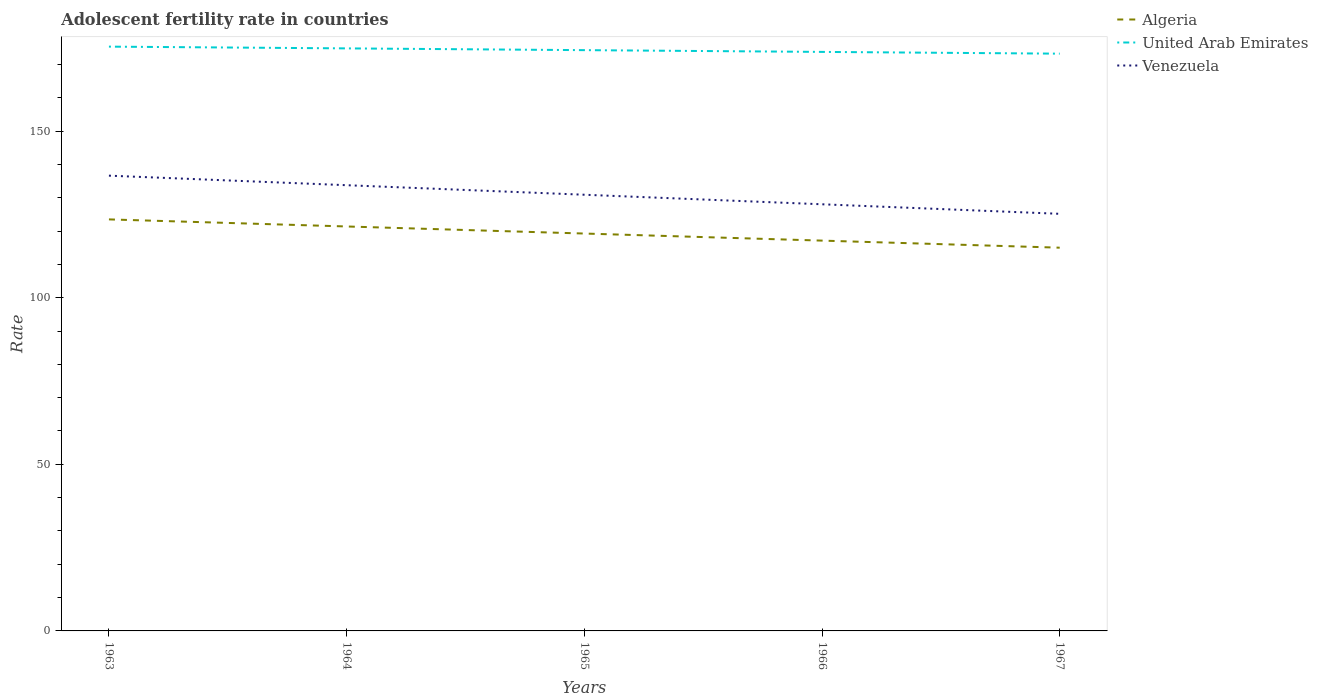Is the number of lines equal to the number of legend labels?
Give a very brief answer. Yes. Across all years, what is the maximum adolescent fertility rate in United Arab Emirates?
Offer a terse response. 173.24. In which year was the adolescent fertility rate in Venezuela maximum?
Your answer should be very brief. 1967. What is the total adolescent fertility rate in United Arab Emirates in the graph?
Your answer should be very brief. 0.53. What is the difference between the highest and the second highest adolescent fertility rate in Algeria?
Provide a succinct answer. 8.49. What is the difference between the highest and the lowest adolescent fertility rate in United Arab Emirates?
Keep it short and to the point. 2. What is the difference between two consecutive major ticks on the Y-axis?
Offer a very short reply. 50. Does the graph contain any zero values?
Provide a succinct answer. No. How are the legend labels stacked?
Your answer should be compact. Vertical. What is the title of the graph?
Provide a short and direct response. Adolescent fertility rate in countries. Does "Argentina" appear as one of the legend labels in the graph?
Keep it short and to the point. No. What is the label or title of the Y-axis?
Provide a short and direct response. Rate. What is the Rate of Algeria in 1963?
Give a very brief answer. 123.5. What is the Rate of United Arab Emirates in 1963?
Give a very brief answer. 175.35. What is the Rate of Venezuela in 1963?
Offer a terse response. 136.63. What is the Rate of Algeria in 1964?
Provide a short and direct response. 121.38. What is the Rate in United Arab Emirates in 1964?
Give a very brief answer. 174.82. What is the Rate of Venezuela in 1964?
Provide a short and direct response. 133.76. What is the Rate in Algeria in 1965?
Your response must be concise. 119.26. What is the Rate in United Arab Emirates in 1965?
Your answer should be very brief. 174.3. What is the Rate of Venezuela in 1965?
Your response must be concise. 130.9. What is the Rate in Algeria in 1966?
Keep it short and to the point. 117.13. What is the Rate in United Arab Emirates in 1966?
Your answer should be very brief. 173.77. What is the Rate of Venezuela in 1966?
Keep it short and to the point. 128.04. What is the Rate of Algeria in 1967?
Make the answer very short. 115.01. What is the Rate of United Arab Emirates in 1967?
Ensure brevity in your answer.  173.24. What is the Rate of Venezuela in 1967?
Your answer should be very brief. 125.17. Across all years, what is the maximum Rate of Algeria?
Your answer should be compact. 123.5. Across all years, what is the maximum Rate of United Arab Emirates?
Offer a terse response. 175.35. Across all years, what is the maximum Rate of Venezuela?
Your answer should be very brief. 136.63. Across all years, what is the minimum Rate of Algeria?
Give a very brief answer. 115.01. Across all years, what is the minimum Rate of United Arab Emirates?
Provide a succinct answer. 173.24. Across all years, what is the minimum Rate of Venezuela?
Offer a very short reply. 125.17. What is the total Rate in Algeria in the graph?
Your answer should be very brief. 596.28. What is the total Rate of United Arab Emirates in the graph?
Make the answer very short. 871.48. What is the total Rate in Venezuela in the graph?
Offer a terse response. 654.51. What is the difference between the Rate in Algeria in 1963 and that in 1964?
Your answer should be compact. 2.12. What is the difference between the Rate in United Arab Emirates in 1963 and that in 1964?
Keep it short and to the point. 0.53. What is the difference between the Rate of Venezuela in 1963 and that in 1964?
Your answer should be very brief. 2.86. What is the difference between the Rate in Algeria in 1963 and that in 1965?
Offer a terse response. 4.24. What is the difference between the Rate in United Arab Emirates in 1963 and that in 1965?
Ensure brevity in your answer.  1.06. What is the difference between the Rate of Venezuela in 1963 and that in 1965?
Provide a short and direct response. 5.73. What is the difference between the Rate in Algeria in 1963 and that in 1966?
Provide a short and direct response. 6.37. What is the difference between the Rate of United Arab Emirates in 1963 and that in 1966?
Your answer should be very brief. 1.58. What is the difference between the Rate of Venezuela in 1963 and that in 1966?
Keep it short and to the point. 8.59. What is the difference between the Rate in Algeria in 1963 and that in 1967?
Your response must be concise. 8.49. What is the difference between the Rate of United Arab Emirates in 1963 and that in 1967?
Offer a very short reply. 2.11. What is the difference between the Rate of Venezuela in 1963 and that in 1967?
Provide a short and direct response. 11.45. What is the difference between the Rate in Algeria in 1964 and that in 1965?
Offer a terse response. 2.12. What is the difference between the Rate of United Arab Emirates in 1964 and that in 1965?
Ensure brevity in your answer.  0.53. What is the difference between the Rate in Venezuela in 1964 and that in 1965?
Provide a short and direct response. 2.86. What is the difference between the Rate of Algeria in 1964 and that in 1966?
Ensure brevity in your answer.  4.24. What is the difference between the Rate in United Arab Emirates in 1964 and that in 1966?
Offer a terse response. 1.06. What is the difference between the Rate in Venezuela in 1964 and that in 1966?
Keep it short and to the point. 5.73. What is the difference between the Rate of Algeria in 1964 and that in 1967?
Ensure brevity in your answer.  6.37. What is the difference between the Rate in United Arab Emirates in 1964 and that in 1967?
Provide a short and direct response. 1.58. What is the difference between the Rate in Venezuela in 1964 and that in 1967?
Offer a terse response. 8.59. What is the difference between the Rate of Algeria in 1965 and that in 1966?
Your answer should be compact. 2.12. What is the difference between the Rate of United Arab Emirates in 1965 and that in 1966?
Offer a very short reply. 0.53. What is the difference between the Rate in Venezuela in 1965 and that in 1966?
Offer a terse response. 2.86. What is the difference between the Rate in Algeria in 1965 and that in 1967?
Keep it short and to the point. 4.24. What is the difference between the Rate of United Arab Emirates in 1965 and that in 1967?
Provide a short and direct response. 1.06. What is the difference between the Rate in Venezuela in 1965 and that in 1967?
Offer a terse response. 5.73. What is the difference between the Rate of Algeria in 1966 and that in 1967?
Provide a short and direct response. 2.12. What is the difference between the Rate in United Arab Emirates in 1966 and that in 1967?
Your answer should be compact. 0.53. What is the difference between the Rate in Venezuela in 1966 and that in 1967?
Make the answer very short. 2.86. What is the difference between the Rate of Algeria in 1963 and the Rate of United Arab Emirates in 1964?
Make the answer very short. -51.32. What is the difference between the Rate of Algeria in 1963 and the Rate of Venezuela in 1964?
Your answer should be compact. -10.26. What is the difference between the Rate in United Arab Emirates in 1963 and the Rate in Venezuela in 1964?
Give a very brief answer. 41.59. What is the difference between the Rate of Algeria in 1963 and the Rate of United Arab Emirates in 1965?
Give a very brief answer. -50.79. What is the difference between the Rate in Algeria in 1963 and the Rate in Venezuela in 1965?
Give a very brief answer. -7.4. What is the difference between the Rate in United Arab Emirates in 1963 and the Rate in Venezuela in 1965?
Your answer should be very brief. 44.45. What is the difference between the Rate of Algeria in 1963 and the Rate of United Arab Emirates in 1966?
Your answer should be very brief. -50.27. What is the difference between the Rate in Algeria in 1963 and the Rate in Venezuela in 1966?
Provide a short and direct response. -4.54. What is the difference between the Rate in United Arab Emirates in 1963 and the Rate in Venezuela in 1966?
Keep it short and to the point. 47.31. What is the difference between the Rate in Algeria in 1963 and the Rate in United Arab Emirates in 1967?
Your answer should be very brief. -49.74. What is the difference between the Rate of Algeria in 1963 and the Rate of Venezuela in 1967?
Provide a short and direct response. -1.67. What is the difference between the Rate of United Arab Emirates in 1963 and the Rate of Venezuela in 1967?
Give a very brief answer. 50.18. What is the difference between the Rate in Algeria in 1964 and the Rate in United Arab Emirates in 1965?
Keep it short and to the point. -52.92. What is the difference between the Rate in Algeria in 1964 and the Rate in Venezuela in 1965?
Offer a terse response. -9.52. What is the difference between the Rate in United Arab Emirates in 1964 and the Rate in Venezuela in 1965?
Ensure brevity in your answer.  43.92. What is the difference between the Rate of Algeria in 1964 and the Rate of United Arab Emirates in 1966?
Keep it short and to the point. -52.39. What is the difference between the Rate of Algeria in 1964 and the Rate of Venezuela in 1966?
Give a very brief answer. -6.66. What is the difference between the Rate of United Arab Emirates in 1964 and the Rate of Venezuela in 1966?
Offer a terse response. 46.78. What is the difference between the Rate of Algeria in 1964 and the Rate of United Arab Emirates in 1967?
Your response must be concise. -51.86. What is the difference between the Rate of Algeria in 1964 and the Rate of Venezuela in 1967?
Your response must be concise. -3.8. What is the difference between the Rate of United Arab Emirates in 1964 and the Rate of Venezuela in 1967?
Make the answer very short. 49.65. What is the difference between the Rate of Algeria in 1965 and the Rate of United Arab Emirates in 1966?
Offer a very short reply. -54.51. What is the difference between the Rate of Algeria in 1965 and the Rate of Venezuela in 1966?
Give a very brief answer. -8.78. What is the difference between the Rate in United Arab Emirates in 1965 and the Rate in Venezuela in 1966?
Provide a succinct answer. 46.26. What is the difference between the Rate of Algeria in 1965 and the Rate of United Arab Emirates in 1967?
Offer a terse response. -53.98. What is the difference between the Rate in Algeria in 1965 and the Rate in Venezuela in 1967?
Make the answer very short. -5.92. What is the difference between the Rate of United Arab Emirates in 1965 and the Rate of Venezuela in 1967?
Your response must be concise. 49.12. What is the difference between the Rate of Algeria in 1966 and the Rate of United Arab Emirates in 1967?
Offer a very short reply. -56.11. What is the difference between the Rate of Algeria in 1966 and the Rate of Venezuela in 1967?
Your response must be concise. -8.04. What is the difference between the Rate in United Arab Emirates in 1966 and the Rate in Venezuela in 1967?
Your answer should be very brief. 48.59. What is the average Rate of Algeria per year?
Give a very brief answer. 119.26. What is the average Rate in United Arab Emirates per year?
Your answer should be very brief. 174.3. What is the average Rate of Venezuela per year?
Give a very brief answer. 130.9. In the year 1963, what is the difference between the Rate of Algeria and Rate of United Arab Emirates?
Offer a very short reply. -51.85. In the year 1963, what is the difference between the Rate of Algeria and Rate of Venezuela?
Ensure brevity in your answer.  -13.13. In the year 1963, what is the difference between the Rate in United Arab Emirates and Rate in Venezuela?
Provide a succinct answer. 38.72. In the year 1964, what is the difference between the Rate in Algeria and Rate in United Arab Emirates?
Provide a succinct answer. -53.44. In the year 1964, what is the difference between the Rate of Algeria and Rate of Venezuela?
Provide a short and direct response. -12.39. In the year 1964, what is the difference between the Rate of United Arab Emirates and Rate of Venezuela?
Give a very brief answer. 41.06. In the year 1965, what is the difference between the Rate of Algeria and Rate of United Arab Emirates?
Offer a very short reply. -55.04. In the year 1965, what is the difference between the Rate in Algeria and Rate in Venezuela?
Your response must be concise. -11.64. In the year 1965, what is the difference between the Rate in United Arab Emirates and Rate in Venezuela?
Provide a short and direct response. 43.39. In the year 1966, what is the difference between the Rate in Algeria and Rate in United Arab Emirates?
Make the answer very short. -56.63. In the year 1966, what is the difference between the Rate of Algeria and Rate of Venezuela?
Provide a succinct answer. -10.9. In the year 1966, what is the difference between the Rate of United Arab Emirates and Rate of Venezuela?
Your response must be concise. 45.73. In the year 1967, what is the difference between the Rate of Algeria and Rate of United Arab Emirates?
Make the answer very short. -58.23. In the year 1967, what is the difference between the Rate in Algeria and Rate in Venezuela?
Your answer should be very brief. -10.16. In the year 1967, what is the difference between the Rate in United Arab Emirates and Rate in Venezuela?
Your response must be concise. 48.06. What is the ratio of the Rate of Algeria in 1963 to that in 1964?
Your answer should be compact. 1.02. What is the ratio of the Rate in United Arab Emirates in 1963 to that in 1964?
Provide a succinct answer. 1. What is the ratio of the Rate in Venezuela in 1963 to that in 1964?
Provide a short and direct response. 1.02. What is the ratio of the Rate in Algeria in 1963 to that in 1965?
Ensure brevity in your answer.  1.04. What is the ratio of the Rate in United Arab Emirates in 1963 to that in 1965?
Keep it short and to the point. 1.01. What is the ratio of the Rate in Venezuela in 1963 to that in 1965?
Your answer should be very brief. 1.04. What is the ratio of the Rate in Algeria in 1963 to that in 1966?
Offer a very short reply. 1.05. What is the ratio of the Rate of United Arab Emirates in 1963 to that in 1966?
Provide a succinct answer. 1.01. What is the ratio of the Rate of Venezuela in 1963 to that in 1966?
Your response must be concise. 1.07. What is the ratio of the Rate in Algeria in 1963 to that in 1967?
Provide a succinct answer. 1.07. What is the ratio of the Rate in United Arab Emirates in 1963 to that in 1967?
Your answer should be compact. 1.01. What is the ratio of the Rate in Venezuela in 1963 to that in 1967?
Offer a terse response. 1.09. What is the ratio of the Rate of Algeria in 1964 to that in 1965?
Your answer should be compact. 1.02. What is the ratio of the Rate in United Arab Emirates in 1964 to that in 1965?
Your answer should be compact. 1. What is the ratio of the Rate of Venezuela in 1964 to that in 1965?
Make the answer very short. 1.02. What is the ratio of the Rate in Algeria in 1964 to that in 1966?
Your response must be concise. 1.04. What is the ratio of the Rate in Venezuela in 1964 to that in 1966?
Provide a short and direct response. 1.04. What is the ratio of the Rate of Algeria in 1964 to that in 1967?
Your response must be concise. 1.06. What is the ratio of the Rate in United Arab Emirates in 1964 to that in 1967?
Your answer should be compact. 1.01. What is the ratio of the Rate in Venezuela in 1964 to that in 1967?
Ensure brevity in your answer.  1.07. What is the ratio of the Rate of Algeria in 1965 to that in 1966?
Your answer should be very brief. 1.02. What is the ratio of the Rate of Venezuela in 1965 to that in 1966?
Provide a short and direct response. 1.02. What is the ratio of the Rate of Algeria in 1965 to that in 1967?
Offer a very short reply. 1.04. What is the ratio of the Rate of United Arab Emirates in 1965 to that in 1967?
Keep it short and to the point. 1.01. What is the ratio of the Rate in Venezuela in 1965 to that in 1967?
Provide a succinct answer. 1.05. What is the ratio of the Rate of Algeria in 1966 to that in 1967?
Give a very brief answer. 1.02. What is the ratio of the Rate of United Arab Emirates in 1966 to that in 1967?
Your response must be concise. 1. What is the ratio of the Rate of Venezuela in 1966 to that in 1967?
Provide a succinct answer. 1.02. What is the difference between the highest and the second highest Rate in Algeria?
Provide a short and direct response. 2.12. What is the difference between the highest and the second highest Rate in United Arab Emirates?
Your answer should be compact. 0.53. What is the difference between the highest and the second highest Rate of Venezuela?
Offer a very short reply. 2.86. What is the difference between the highest and the lowest Rate of Algeria?
Offer a terse response. 8.49. What is the difference between the highest and the lowest Rate in United Arab Emirates?
Your response must be concise. 2.11. What is the difference between the highest and the lowest Rate in Venezuela?
Provide a short and direct response. 11.45. 